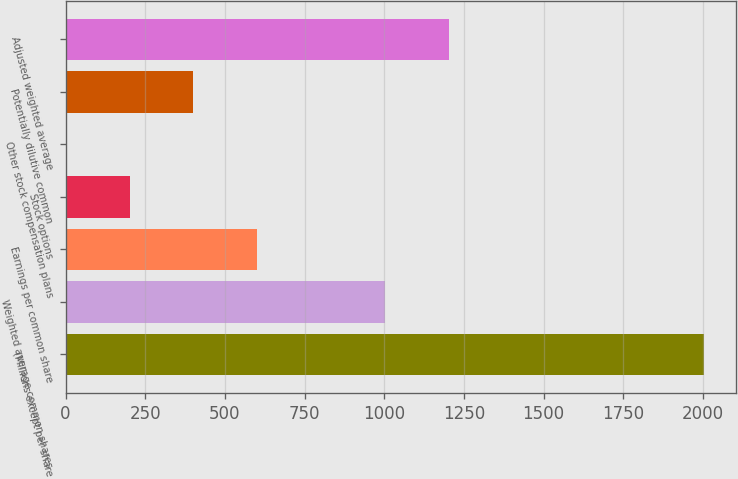Convert chart to OTSL. <chart><loc_0><loc_0><loc_500><loc_500><bar_chart><fcel>(Millions except per share<fcel>Weighted average common shares<fcel>Earnings per common share<fcel>Stock options<fcel>Other stock compensation plans<fcel>Potentially dilutive common<fcel>Adjusted weighted average<nl><fcel>2004<fcel>1002.3<fcel>601.62<fcel>200.94<fcel>0.6<fcel>401.28<fcel>1202.64<nl></chart> 